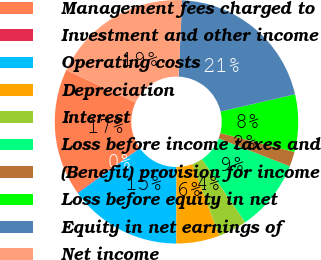Convert chart. <chart><loc_0><loc_0><loc_500><loc_500><pie_chart><fcel>Management fees charged to<fcel>Investment and other income<fcel>Operating costs<fcel>Depreciation<fcel>Interest<fcel>Loss before income taxes and<fcel>(Benefit) provision for income<fcel>Loss before equity in net<fcel>Equity in net earnings of<fcel>Net income<nl><fcel>16.87%<fcel>0.09%<fcel>15.0%<fcel>5.73%<fcel>3.85%<fcel>9.49%<fcel>1.97%<fcel>7.61%<fcel>20.63%<fcel>18.75%<nl></chart> 